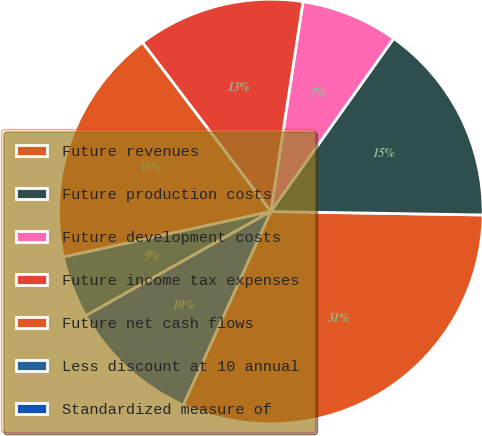Convert chart. <chart><loc_0><loc_0><loc_500><loc_500><pie_chart><fcel>Future revenues<fcel>Future production costs<fcel>Future development costs<fcel>Future income tax expenses<fcel>Future net cash flows<fcel>Less discount at 10 annual<fcel>Standardized measure of<nl><fcel>31.5%<fcel>15.43%<fcel>7.4%<fcel>12.76%<fcel>18.11%<fcel>4.72%<fcel>10.08%<nl></chart> 